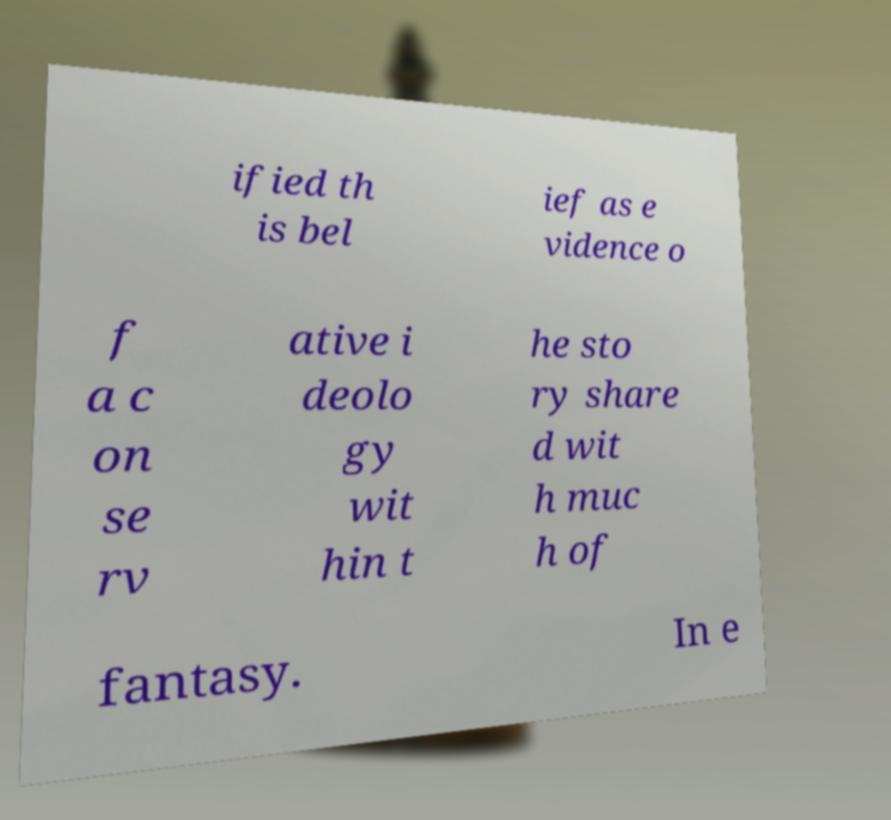Please read and relay the text visible in this image. What does it say? ified th is bel ief as e vidence o f a c on se rv ative i deolo gy wit hin t he sto ry share d wit h muc h of fantasy. In e 